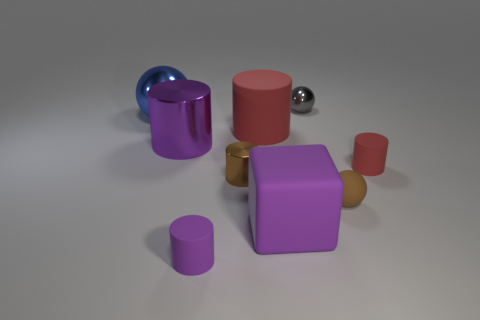Subtract all tiny brown rubber spheres. How many spheres are left? 2 Subtract all brown spheres. How many red cylinders are left? 2 Subtract all blue spheres. How many spheres are left? 2 Subtract all spheres. How many objects are left? 6 Subtract 4 cylinders. How many cylinders are left? 1 Subtract 2 red cylinders. How many objects are left? 7 Subtract all yellow cylinders. Subtract all green blocks. How many cylinders are left? 5 Subtract all large matte cylinders. Subtract all large purple objects. How many objects are left? 6 Add 9 brown matte spheres. How many brown matte spheres are left? 10 Add 6 tiny yellow rubber objects. How many tiny yellow rubber objects exist? 6 